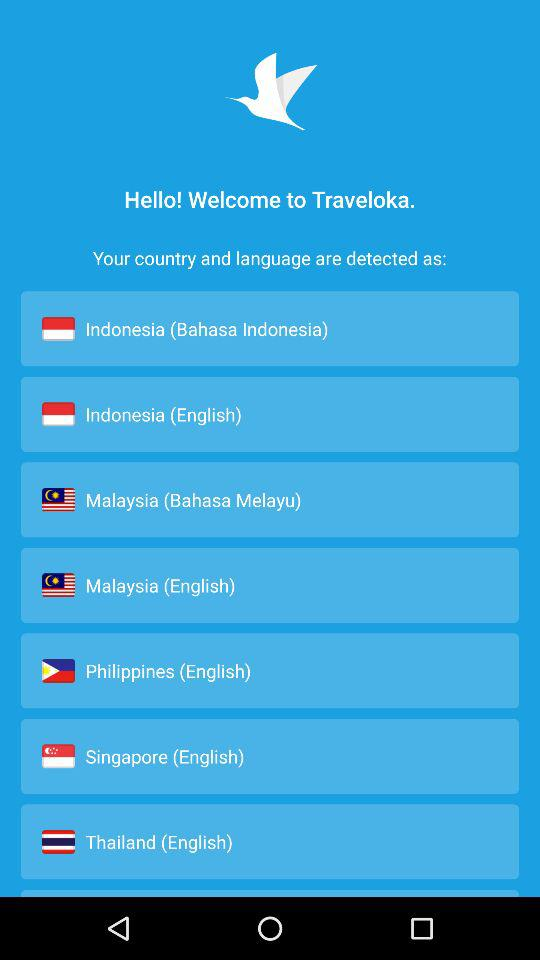What is the language of Thailand? The language of Thailand is English. 